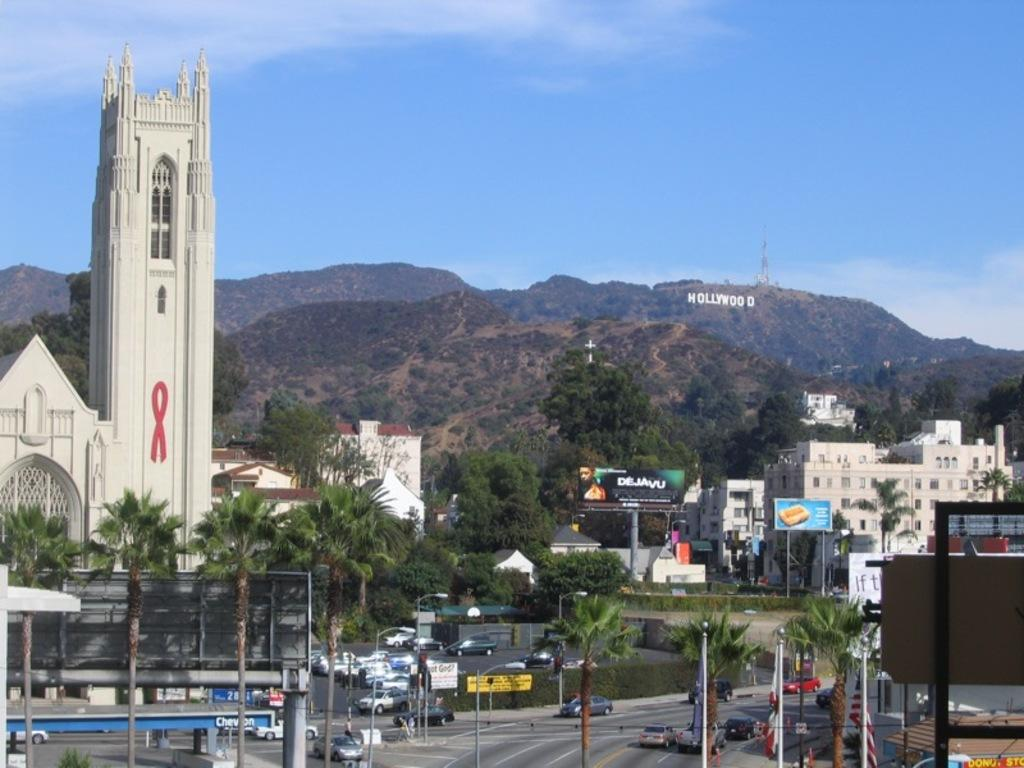What type of structures can be seen in the image? There are buildings in the image. What natural elements are present in the image? There are trees, plants, grass, and hills in the image. What man-made objects can be seen in the image? There are poles, a road, vehicles, and a tower in the image. What is visible in the sky in the image? There is sky visible in the image, with clouds present. What type of wool is being used to create the name of the tower in the image? There is no wool or name of the tower present in the image. How many times does the tower fall in the image? There is no tower falling in the image; it is standing upright. 